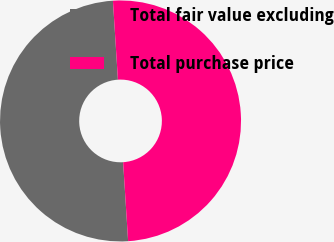Convert chart to OTSL. <chart><loc_0><loc_0><loc_500><loc_500><pie_chart><fcel>Total fair value excluding<fcel>Total purchase price<nl><fcel>50.0%<fcel>50.0%<nl></chart> 